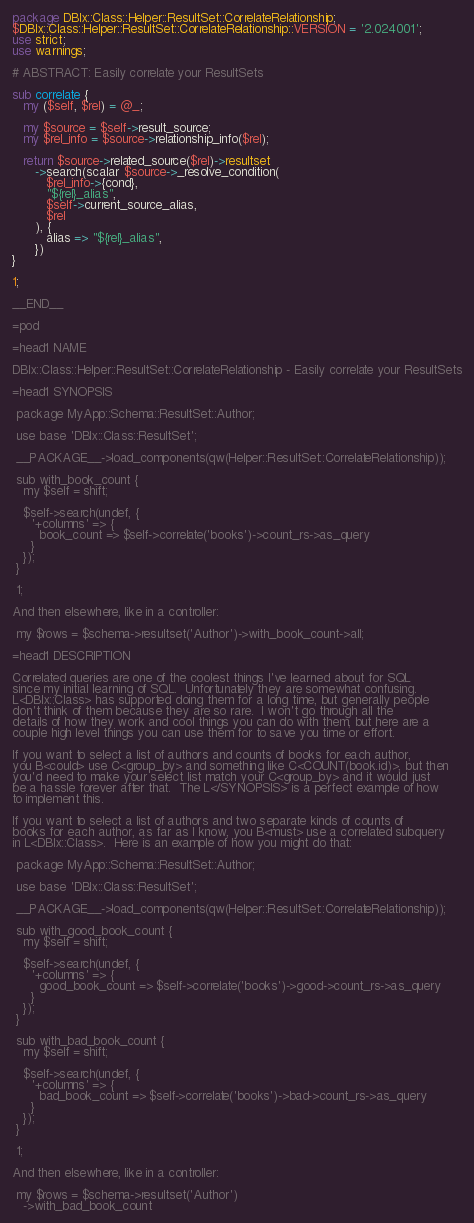<code> <loc_0><loc_0><loc_500><loc_500><_Perl_>package DBIx::Class::Helper::ResultSet::CorrelateRelationship;
$DBIx::Class::Helper::ResultSet::CorrelateRelationship::VERSION = '2.024001';
use strict;
use warnings;

# ABSTRACT: Easily correlate your ResultSets

sub correlate {
   my ($self, $rel) = @_;

   my $source = $self->result_source;
   my $rel_info = $source->relationship_info($rel);

   return $source->related_source($rel)->resultset
      ->search(scalar $source->_resolve_condition(
         $rel_info->{cond},
         "${rel}_alias",
         $self->current_source_alias,
         $rel
      ), {
         alias => "${rel}_alias",
      })
}

1;

__END__

=pod

=head1 NAME

DBIx::Class::Helper::ResultSet::CorrelateRelationship - Easily correlate your ResultSets

=head1 SYNOPSIS

 package MyApp::Schema::ResultSet::Author;

 use base 'DBIx::Class::ResultSet';

 __PACKAGE__->load_components(qw(Helper::ResultSet::CorrelateRelationship));

 sub with_book_count {
   my $self = shift;

   $self->search(undef, {
     '+columns' => {
       book_count => $self->correlate('books')->count_rs->as_query
     }
   });
 }

 1;

And then elsewhere, like in a controller:

 my $rows = $schema->resultset('Author')->with_book_count->all;

=head1 DESCRIPTION

Correlated queries are one of the coolest things I've learned about for SQL
since my initial learning of SQL.  Unfortunately they are somewhat confusing.
L<DBIx::Class> has supported doing them for a long time, but generally people
don't think of them because they are so rare.  I won't go through all the
details of how they work and cool things you can do with them, but here are a
couple high level things you can use them for to save you time or effort.

If you want to select a list of authors and counts of books for each author,
you B<could> use C<group_by> and something like C<COUNT(book.id)>, but then
you'd need to make your select list match your C<group_by> and it would just
be a hassle forever after that.  The L</SYNOPSIS> is a perfect example of how
to implement this.

If you want to select a list of authors and two separate kinds of counts of
books for each author, as far as I know, you B<must> use a correlated subquery
in L<DBIx::Class>.  Here is an example of how you might do that:

 package MyApp::Schema::ResultSet::Author;

 use base 'DBIx::Class::ResultSet';

 __PACKAGE__->load_components(qw(Helper::ResultSet::CorrelateRelationship));

 sub with_good_book_count {
   my $self = shift;

   $self->search(undef, {
     '+columns' => {
       good_book_count => $self->correlate('books')->good->count_rs->as_query
     }
   });
 }

 sub with_bad_book_count {
   my $self = shift;

   $self->search(undef, {
     '+columns' => {
       bad_book_count => $self->correlate('books')->bad->count_rs->as_query
     }
   });
 }

 1;

And then elsewhere, like in a controller:

 my $rows = $schema->resultset('Author')
   ->with_bad_book_count</code> 